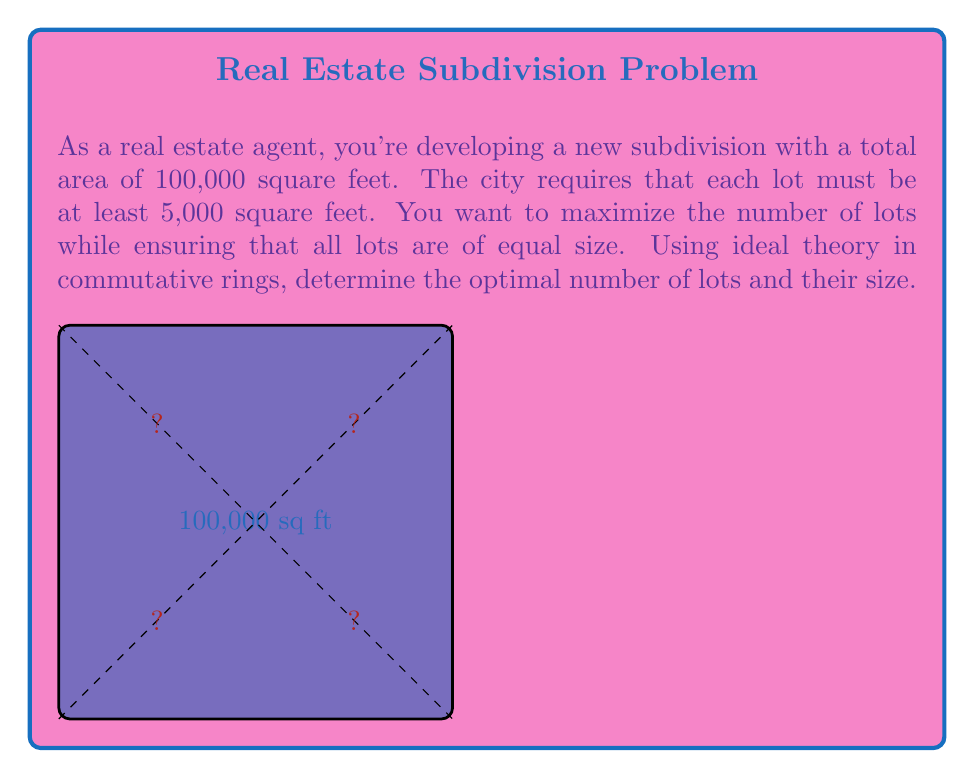Provide a solution to this math problem. Let's approach this problem using ideal theory in commutative rings:

1) Let $R$ be the ring of integers and $I$ be the ideal generated by 5000 (the minimum lot size) in $R$. So, $I = (5000)$.

2) The total area 100,000 can be represented as an element of $R/I$, the quotient ring of $R$ modulo $I$.

3) In $R/I$, 100,000 ≡ 0 (mod 5000), because 100,000 is divisible by 5000.

4) We want to find the largest number $n$ such that $100,000/n$ is an integer multiple of 5000. This is equivalent to finding the largest $n$ such that $n | 20$ (since 100,000/5000 = 20).

5) The divisors of 20 are 1, 2, 4, 5, 10, and 20.

6) The largest divisor of 20 is 20 itself.

7) Therefore, the optimal number of lots is 20.

8) The size of each lot will be 100,000 / 20 = 5,000 square feet.

This solution maximizes the number of lots while keeping them all equal in size and meeting the minimum size requirement.
Answer: 20 lots of 5,000 sq ft each 